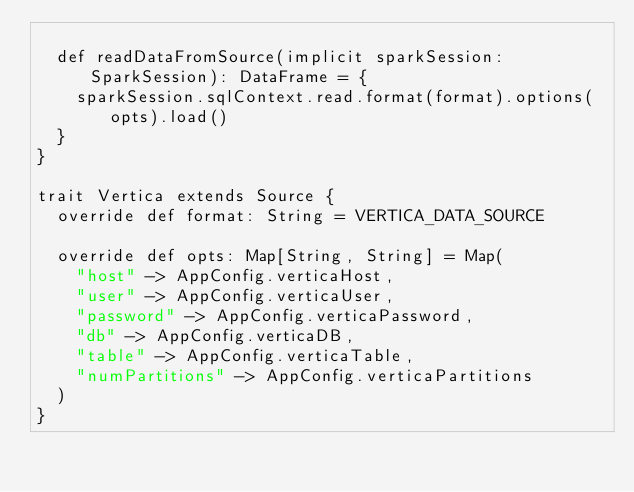Convert code to text. <code><loc_0><loc_0><loc_500><loc_500><_Scala_>
  def readDataFromSource(implicit sparkSession: SparkSession): DataFrame = {
    sparkSession.sqlContext.read.format(format).options(opts).load()
  }
}

trait Vertica extends Source {
  override def format: String = VERTICA_DATA_SOURCE

  override def opts: Map[String, String] = Map(
    "host" -> AppConfig.verticaHost,
    "user" -> AppConfig.verticaUser,
    "password" -> AppConfig.verticaPassword,
    "db" -> AppConfig.verticaDB,
    "table" -> AppConfig.verticaTable,
    "numPartitions" -> AppConfig.verticaPartitions
  )
}
</code> 